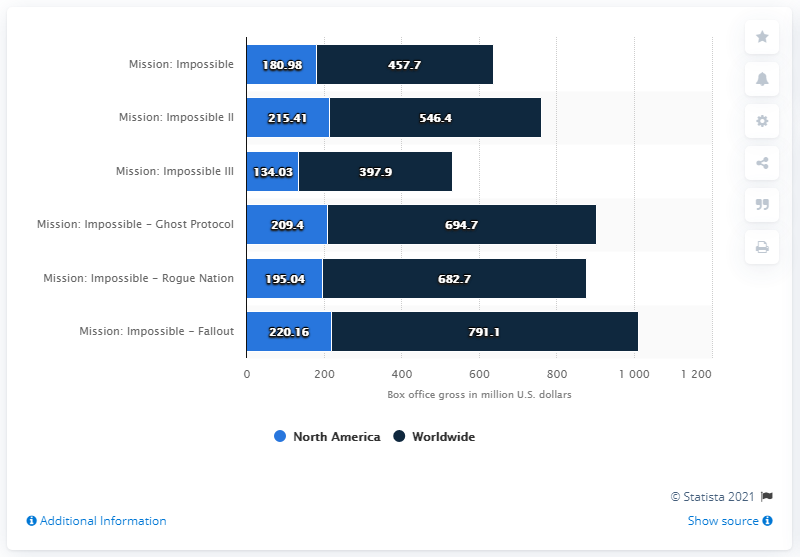Draw attention to some important aspects in this diagram. The gross of Mission: Impossible - Fallout was 220.16 million dollars. 